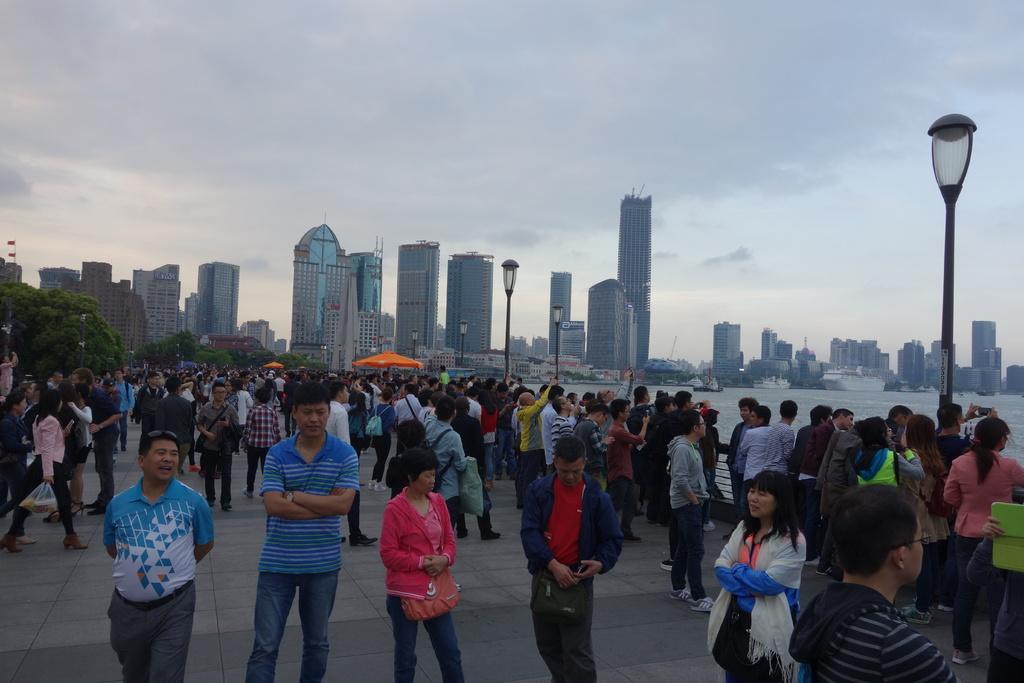Please provide a concise description of this image. In this image we can see the people standing on the ground. And there are buildings, light poles, water, umbrellas and sky in the background. 